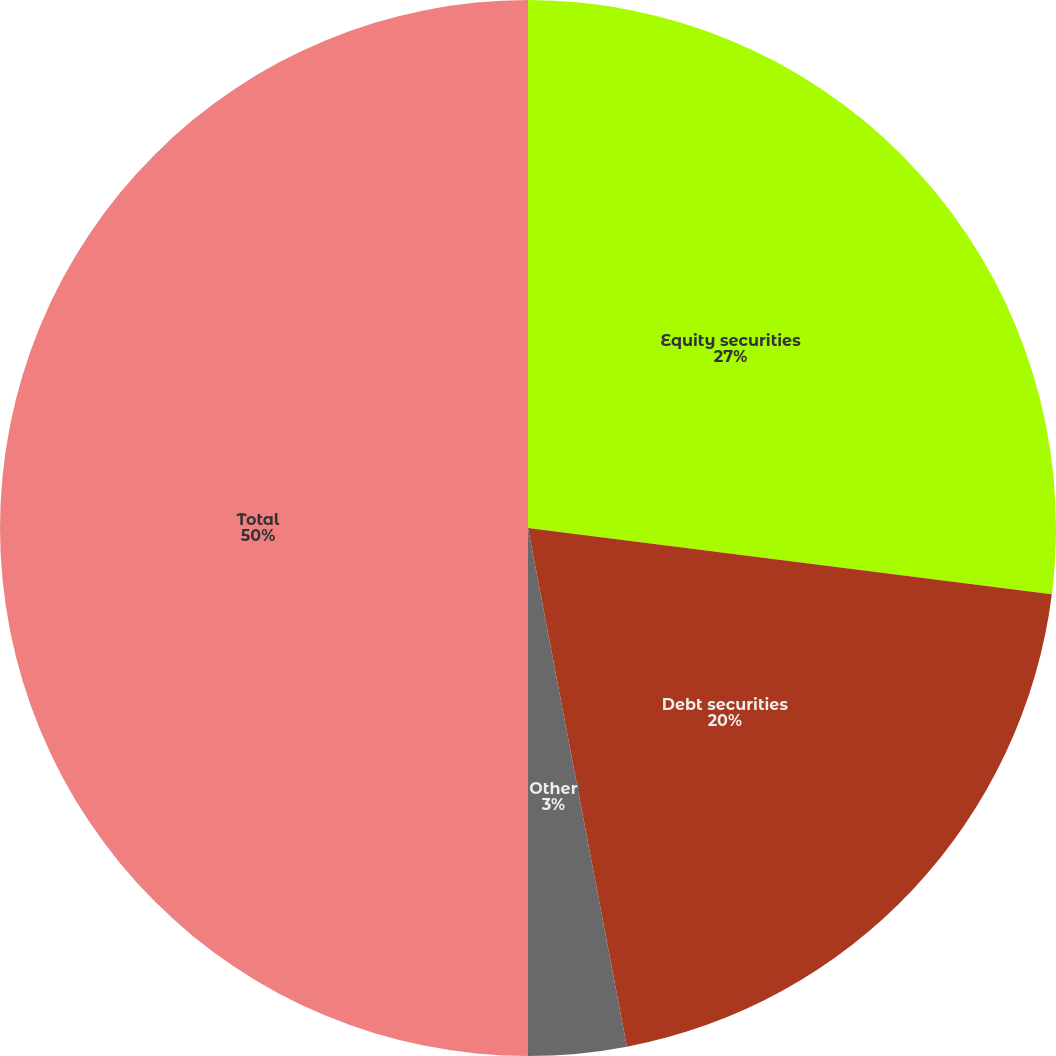<chart> <loc_0><loc_0><loc_500><loc_500><pie_chart><fcel>Equity securities<fcel>Debt securities<fcel>Other<fcel>Total<nl><fcel>27.0%<fcel>20.0%<fcel>3.0%<fcel>50.0%<nl></chart> 